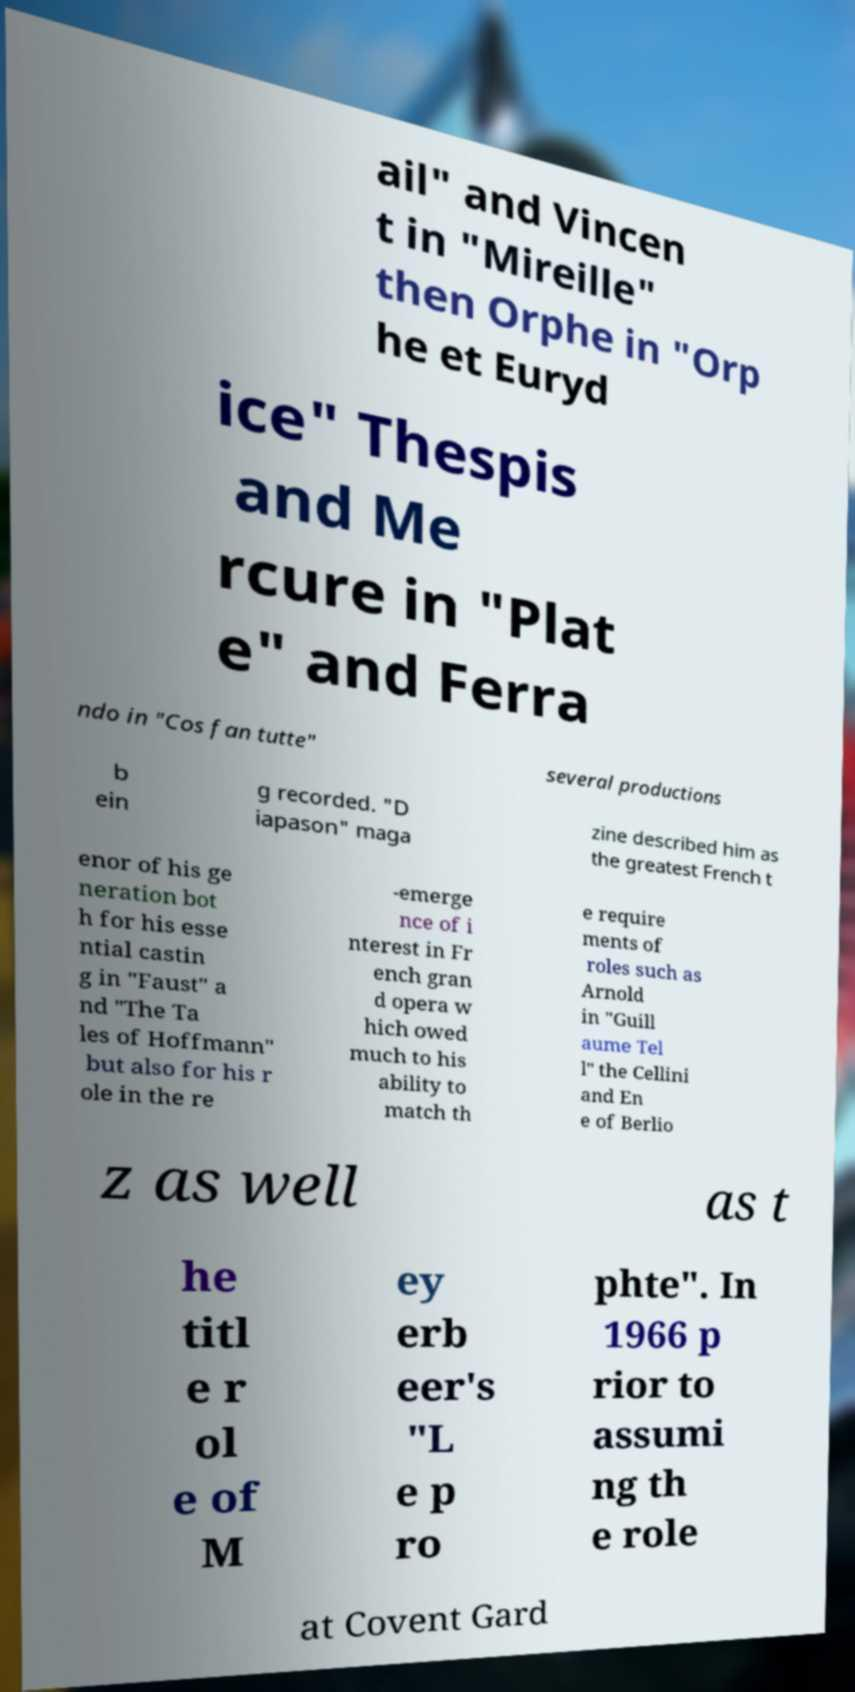What messages or text are displayed in this image? I need them in a readable, typed format. ail" and Vincen t in "Mireille" then Orphe in "Orp he et Euryd ice" Thespis and Me rcure in "Plat e" and Ferra ndo in "Cos fan tutte" several productions b ein g recorded. "D iapason" maga zine described him as the greatest French t enor of his ge neration bot h for his esse ntial castin g in "Faust" a nd "The Ta les of Hoffmann" but also for his r ole in the re -emerge nce of i nterest in Fr ench gran d opera w hich owed much to his ability to match th e require ments of roles such as Arnold in "Guill aume Tel l" the Cellini and En e of Berlio z as well as t he titl e r ol e of M ey erb eer's "L e p ro phte". In 1966 p rior to assumi ng th e role at Covent Gard 